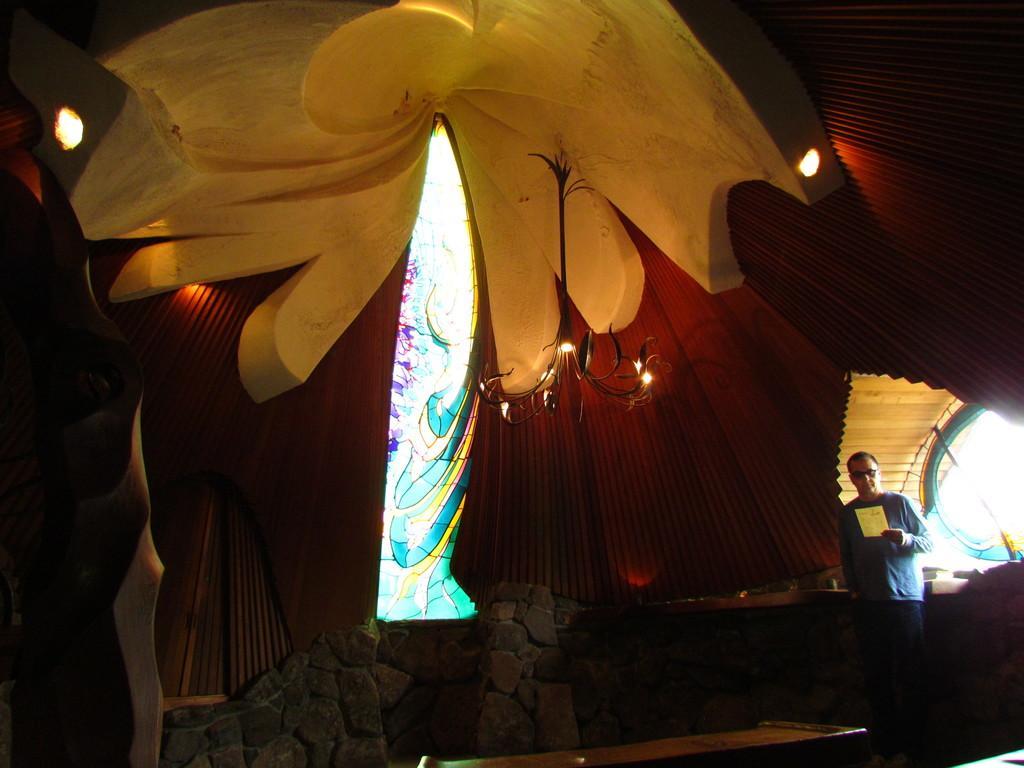In one or two sentences, can you explain what this image depicts? In this image we can see a person standing on the floor holding a paper. We can also see some stones, a table, wall, windows, a chandelier and a roof with some lights. 